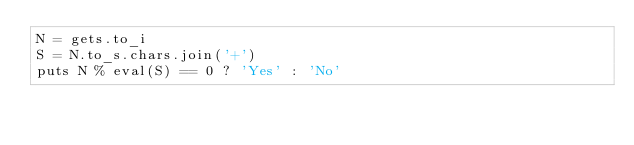<code> <loc_0><loc_0><loc_500><loc_500><_Ruby_>N = gets.to_i
S = N.to_s.chars.join('+')
puts N % eval(S) == 0 ? 'Yes' : 'No'</code> 